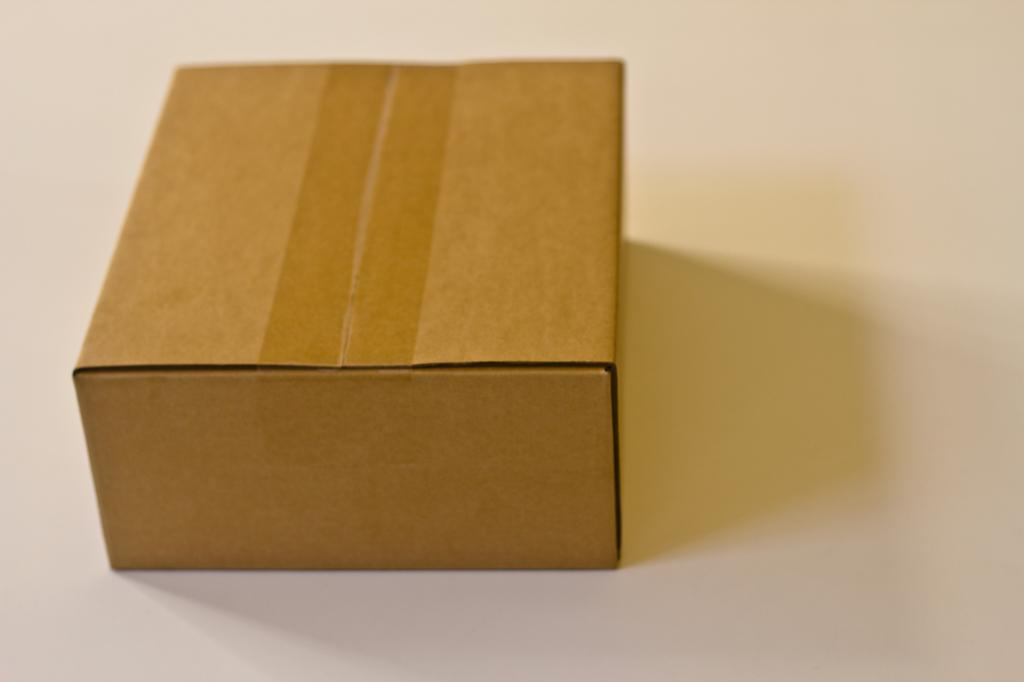What object is present in the image? There is a box in the image. What material is the box made of? The box is made up of paper board. What type of toothbrush is included in the box in the image? There is no toothbrush present in the image; it only features a box made of paper board. What type of wine is being stored in the box in the image? There is no wine present in the image; it only features a box made of paper board. 